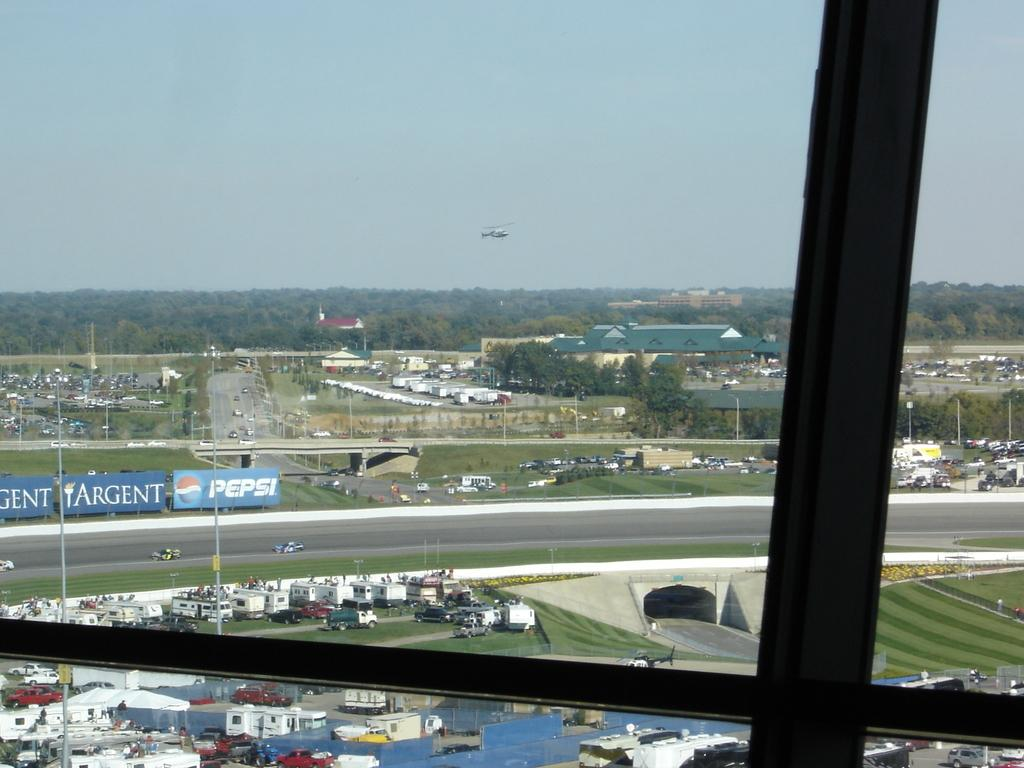<image>
Describe the image concisely. An aerial view of parked cars with a nearby Pepsi banner. 